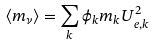<formula> <loc_0><loc_0><loc_500><loc_500>\langle m _ { \nu } \rangle = \sum _ { k } \phi _ { k } m _ { k } U _ { e , k } ^ { 2 }</formula> 